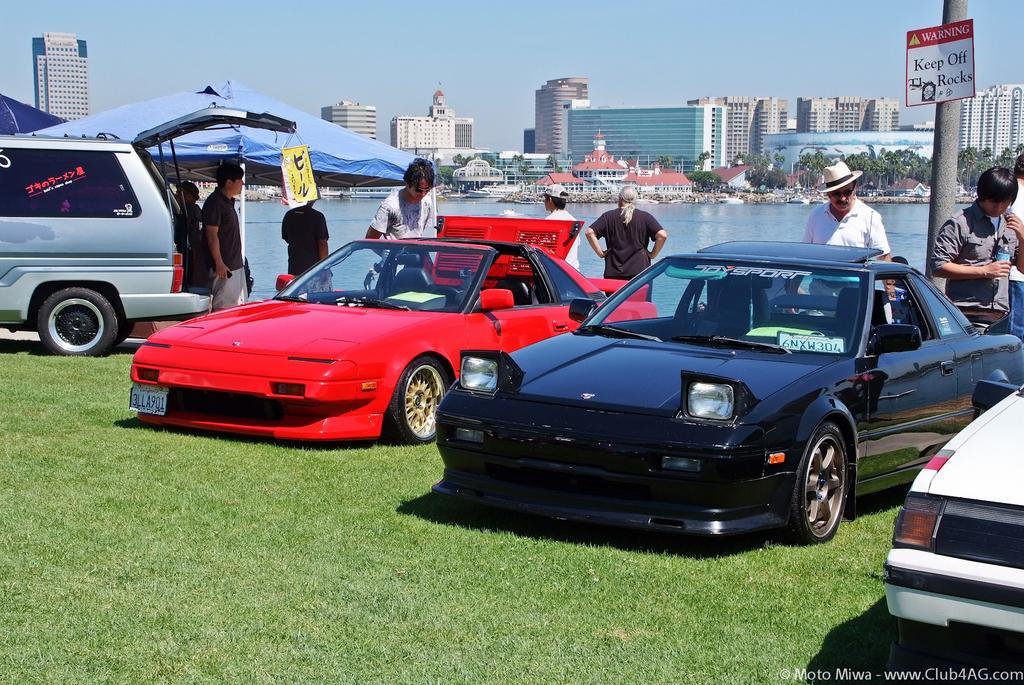In one or two sentences, can you explain what this image depicts? In this image in front there are cars on the surface of the grass. Beside the cars there are people. In the center of the image there is water. On the left side of the image there are tents. In the background of the image there are buildings, trees and sky. There is some text on the right side of the image. 